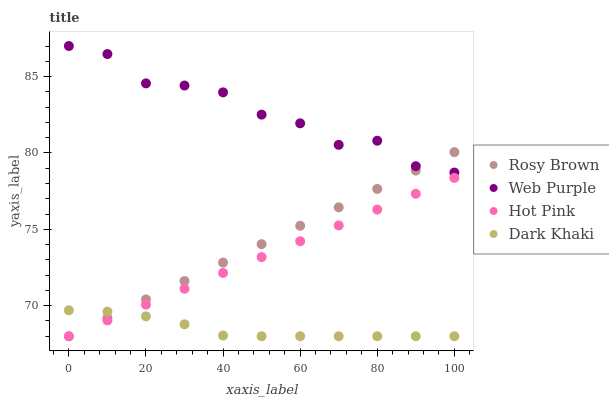Does Dark Khaki have the minimum area under the curve?
Answer yes or no. Yes. Does Web Purple have the maximum area under the curve?
Answer yes or no. Yes. Does Rosy Brown have the minimum area under the curve?
Answer yes or no. No. Does Rosy Brown have the maximum area under the curve?
Answer yes or no. No. Is Rosy Brown the smoothest?
Answer yes or no. Yes. Is Web Purple the roughest?
Answer yes or no. Yes. Is Web Purple the smoothest?
Answer yes or no. No. Is Rosy Brown the roughest?
Answer yes or no. No. Does Dark Khaki have the lowest value?
Answer yes or no. Yes. Does Web Purple have the lowest value?
Answer yes or no. No. Does Web Purple have the highest value?
Answer yes or no. Yes. Does Rosy Brown have the highest value?
Answer yes or no. No. Is Dark Khaki less than Web Purple?
Answer yes or no. Yes. Is Web Purple greater than Hot Pink?
Answer yes or no. Yes. Does Dark Khaki intersect Rosy Brown?
Answer yes or no. Yes. Is Dark Khaki less than Rosy Brown?
Answer yes or no. No. Is Dark Khaki greater than Rosy Brown?
Answer yes or no. No. Does Dark Khaki intersect Web Purple?
Answer yes or no. No. 